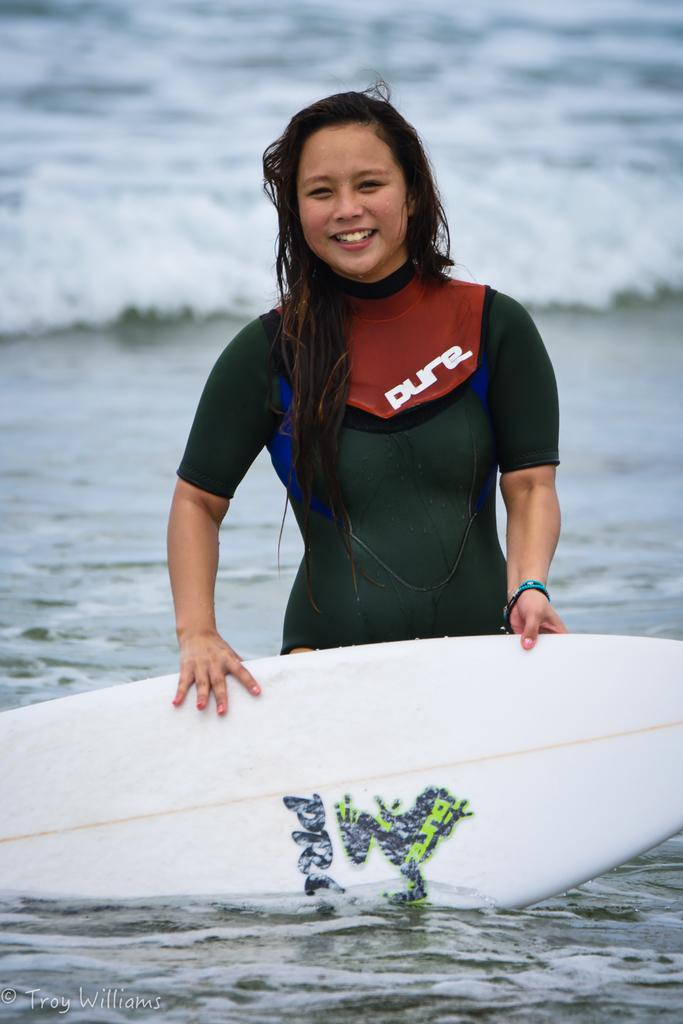Who is present in the image? There is a woman in the image. What is the woman doing in the image? The woman is standing in water. What object is the woman holding in the image? The woman is holding a surfboard. What type of pen is the woman using to write in the water? There is no pen present in the image, and the woman is not writing in the water. 